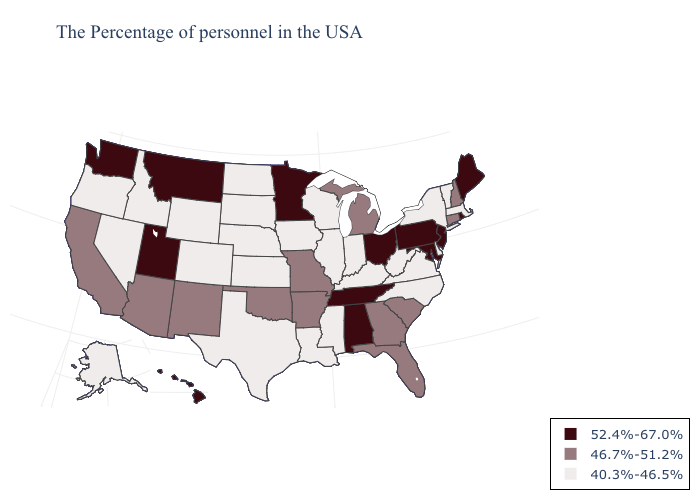What is the value of Louisiana?
Short answer required. 40.3%-46.5%. What is the value of West Virginia?
Keep it brief. 40.3%-46.5%. Among the states that border California , does Arizona have the lowest value?
Keep it brief. No. Name the states that have a value in the range 46.7%-51.2%?
Be succinct. New Hampshire, Connecticut, South Carolina, Florida, Georgia, Michigan, Missouri, Arkansas, Oklahoma, New Mexico, Arizona, California. Does Connecticut have the highest value in the Northeast?
Give a very brief answer. No. What is the value of Nebraska?
Keep it brief. 40.3%-46.5%. What is the value of South Dakota?
Be succinct. 40.3%-46.5%. Among the states that border Ohio , does Kentucky have the lowest value?
Concise answer only. Yes. Which states have the lowest value in the MidWest?
Keep it brief. Indiana, Wisconsin, Illinois, Iowa, Kansas, Nebraska, South Dakota, North Dakota. Among the states that border Georgia , which have the lowest value?
Write a very short answer. North Carolina. Which states have the lowest value in the USA?
Keep it brief. Massachusetts, Vermont, New York, Delaware, Virginia, North Carolina, West Virginia, Kentucky, Indiana, Wisconsin, Illinois, Mississippi, Louisiana, Iowa, Kansas, Nebraska, Texas, South Dakota, North Dakota, Wyoming, Colorado, Idaho, Nevada, Oregon, Alaska. What is the value of Illinois?
Answer briefly. 40.3%-46.5%. What is the value of Alaska?
Write a very short answer. 40.3%-46.5%. What is the lowest value in the USA?
Keep it brief. 40.3%-46.5%. Which states have the lowest value in the USA?
Quick response, please. Massachusetts, Vermont, New York, Delaware, Virginia, North Carolina, West Virginia, Kentucky, Indiana, Wisconsin, Illinois, Mississippi, Louisiana, Iowa, Kansas, Nebraska, Texas, South Dakota, North Dakota, Wyoming, Colorado, Idaho, Nevada, Oregon, Alaska. 